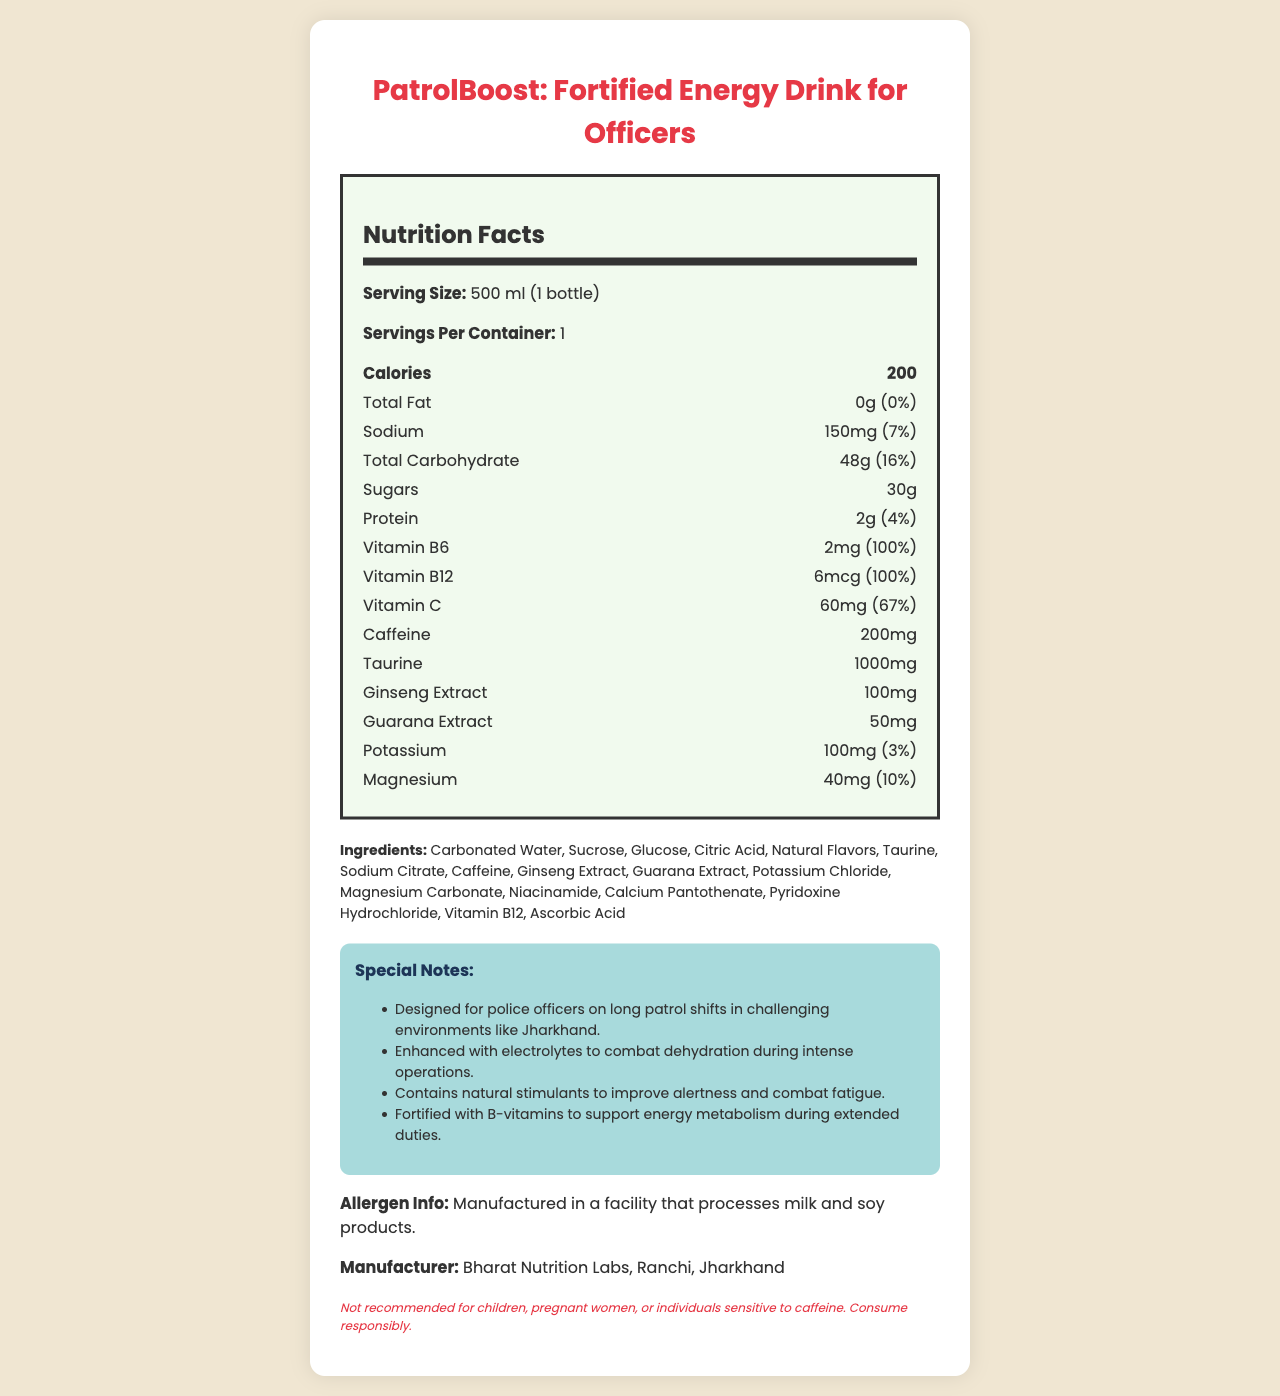what is the product name? The product name is clearly stated at the top of the document, "PatrolBoost: Fortified Energy Drink for Officers".
Answer: PatrolBoost: Fortified Energy Drink for Officers what is the serving size? The serving size is mentioned right under the "Nutrition Facts" heading as "500 ml (1 bottle)".
Answer: 500 ml (1 bottle) how many calories does one serving contain? The calories per serving are listed right under the "Nutrition Facts" heading as "200".
Answer: 200 how much sodium is in one serving? The amount of sodium per serving is stated as "150 mg" in the nutrition information section.
Answer: 150 mg what is the percentage of the daily value for Vitamin C per serving? The daily value percentage for Vitamin C is provided as "67%" in the nutrition facts section.
Answer: 67% how much caffeine is in one serving? A. 100mg B. 150mg C. 200mg The document states that one serving contains "200mg" of caffeine.
Answer: C. 200mg which ingredient is not listed in the ingredients section? A. Citric Acid B. Taurine C. Aspartame D. Guarana Extract The ingredients section does not list "Aspartame"; the other options (Citric Acid, Taurine, and Guarana Extract) are listed.
Answer: C. Aspartame is this product recommended for children? The disclaimer at the bottom of the document states, "Not recommended for children".
Answer: No summarize the main idea of the document in a few sentences The document is a comprehensive presentation of the nutritional content, ingredients, and benefits of the PatrolBoost energy drink, tailored for police officers on extended patrols.
Answer: The document provides the nutrition facts and ingredients for a fortified energy drink named "PatrolBoost: Fortified Energy Drink for Officers," designed for police officers on long patrol shifts. It details the serving size, calories, and amounts of various nutrients and vitamins. Additional notes highlight the product's benefits, such as combating dehydration, improving alertness, and supporting energy metabolism. It also includes allergen information, manufacturer details, and a disclaimer about consumption recommendations. can we determine how this drink affects hydration? Although the document mentions that the drink is enhanced with electrolytes to combat dehydration, it does not provide specific details on how effective it is in terms of hydrating the user.
Answer: Not enough information how many milligrams of taurine are present in this beverage? The nutrition facts section lists "Taurine: 1000mg" per serving.
Answer: 1000mg what is the daily value percentage of potassium in one serving? The daily value percentage of potassium per serving is listed as "3%" in the nutrition information section.
Answer: 3% how many servings are there per container? The document specifies that there is "1" serving per container.
Answer: 1 which vitamin is present in the highest daily value percentage? A. Vitamin C B. Vitamin B6 C. Vitamin B12 Both Vitamin B6 and Vitamin B12 have a 100% daily value, but since the question asks for the highest, B. Vitamin B6 is as correct as B. Vitamin B12.
Answer: B. Vitamin B6 what type of flavors are included in the ingredients? In the ingredients section, "Natural Flavors" is specifically listed.
Answer: Natural Flavors how much protein is in one serving? The nutrition facts state that there is "2g" of protein per serving.
Answer: 2g 